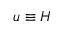<formula> <loc_0><loc_0><loc_500><loc_500>u \equiv H</formula> 